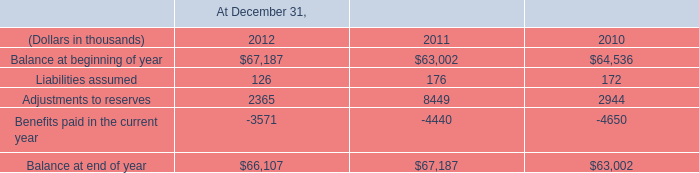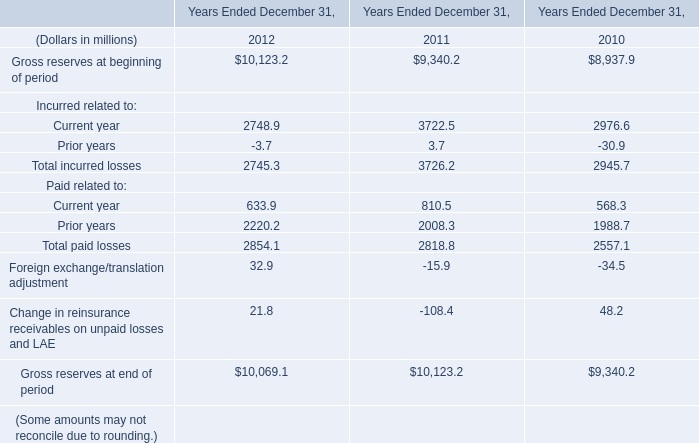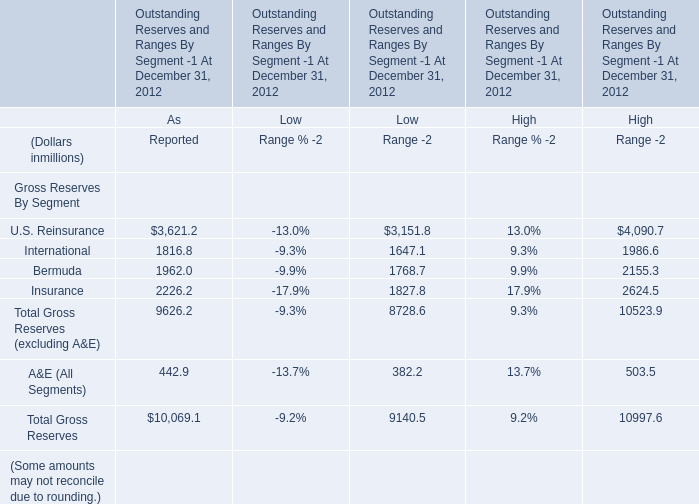What is the sum of U.S. Reinsurance, International and Bermuda for As Reported? (in million) 
Computations: ((3621.2 + 1816.8) + 1962)
Answer: 7400.0. 